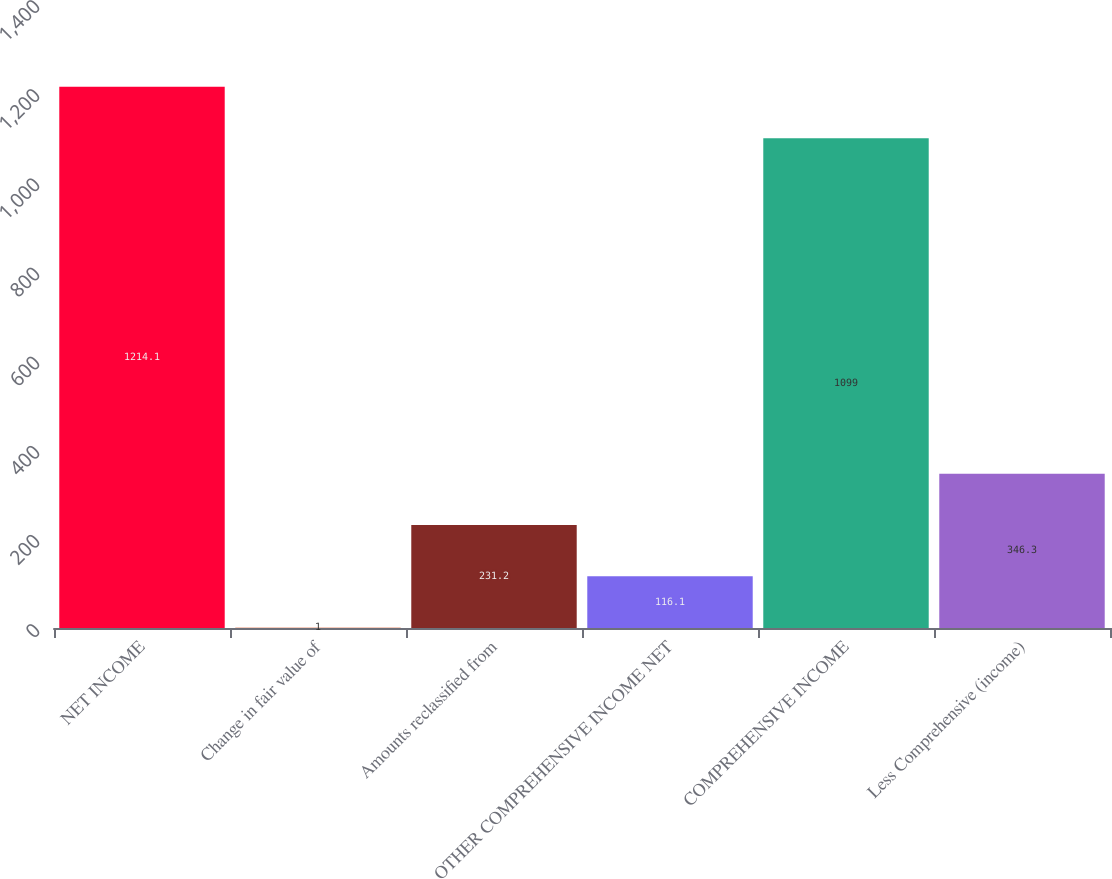<chart> <loc_0><loc_0><loc_500><loc_500><bar_chart><fcel>NET INCOME<fcel>Change in fair value of<fcel>Amounts reclassified from<fcel>OTHER COMPREHENSIVE INCOME NET<fcel>COMPREHENSIVE INCOME<fcel>Less Comprehensive (income)<nl><fcel>1214.1<fcel>1<fcel>231.2<fcel>116.1<fcel>1099<fcel>346.3<nl></chart> 